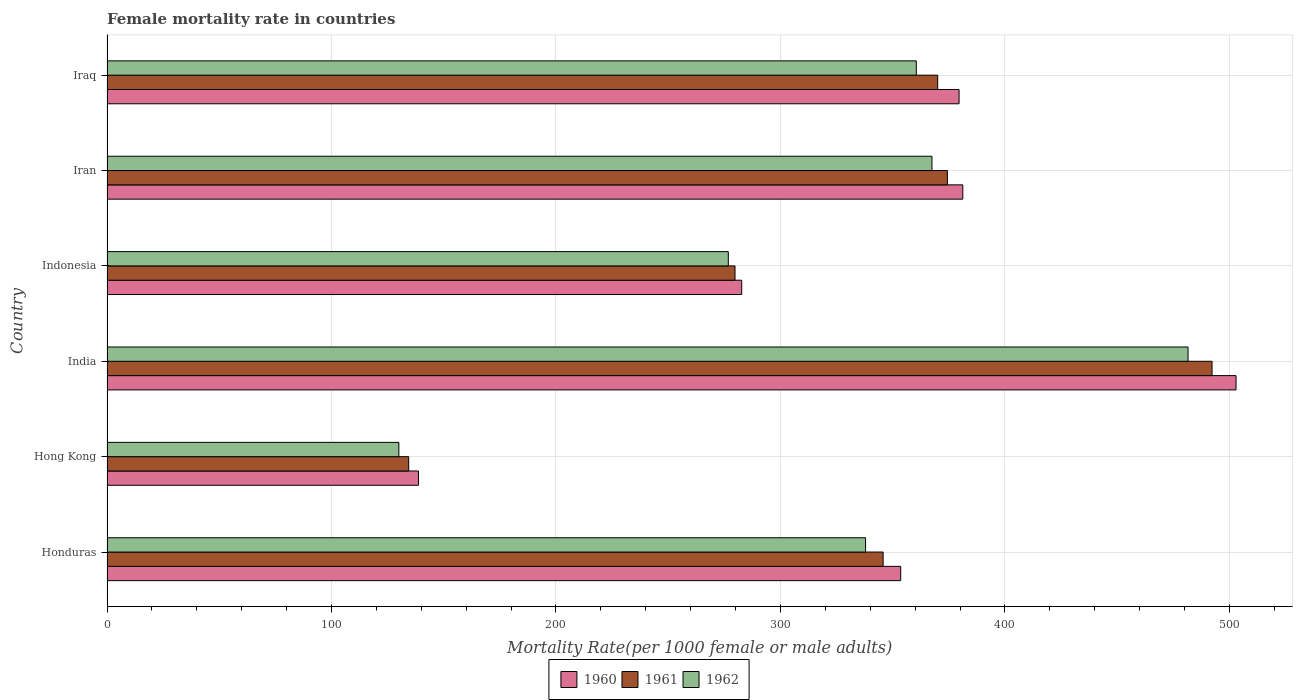How many groups of bars are there?
Make the answer very short. 6. Are the number of bars per tick equal to the number of legend labels?
Your answer should be compact. Yes. Are the number of bars on each tick of the Y-axis equal?
Your response must be concise. Yes. How many bars are there on the 4th tick from the top?
Keep it short and to the point. 3. How many bars are there on the 2nd tick from the bottom?
Your response must be concise. 3. What is the label of the 1st group of bars from the top?
Ensure brevity in your answer.  Iraq. What is the female mortality rate in 1962 in Hong Kong?
Your answer should be very brief. 130.02. Across all countries, what is the maximum female mortality rate in 1961?
Offer a terse response. 492.27. Across all countries, what is the minimum female mortality rate in 1961?
Offer a terse response. 134.39. In which country was the female mortality rate in 1962 maximum?
Your response must be concise. India. In which country was the female mortality rate in 1960 minimum?
Ensure brevity in your answer.  Hong Kong. What is the total female mortality rate in 1962 in the graph?
Provide a short and direct response. 1954.32. What is the difference between the female mortality rate in 1962 in Honduras and that in India?
Ensure brevity in your answer.  -143.67. What is the difference between the female mortality rate in 1961 in Hong Kong and the female mortality rate in 1962 in Indonesia?
Your response must be concise. -142.38. What is the average female mortality rate in 1960 per country?
Offer a very short reply. 339.81. What is the difference between the female mortality rate in 1960 and female mortality rate in 1962 in India?
Your answer should be compact. 21.38. In how many countries, is the female mortality rate in 1961 greater than 480 ?
Provide a succinct answer. 1. What is the ratio of the female mortality rate in 1960 in Iran to that in Iraq?
Give a very brief answer. 1. Is the female mortality rate in 1960 in Hong Kong less than that in Indonesia?
Make the answer very short. Yes. Is the difference between the female mortality rate in 1960 in Indonesia and Iran greater than the difference between the female mortality rate in 1962 in Indonesia and Iran?
Your response must be concise. No. What is the difference between the highest and the second highest female mortality rate in 1960?
Your answer should be compact. 121.72. What is the difference between the highest and the lowest female mortality rate in 1961?
Keep it short and to the point. 357.88. In how many countries, is the female mortality rate in 1960 greater than the average female mortality rate in 1960 taken over all countries?
Your answer should be very brief. 4. Is the sum of the female mortality rate in 1960 in Honduras and Indonesia greater than the maximum female mortality rate in 1961 across all countries?
Keep it short and to the point. Yes. What does the 1st bar from the bottom in Iran represents?
Make the answer very short. 1960. Is it the case that in every country, the sum of the female mortality rate in 1960 and female mortality rate in 1961 is greater than the female mortality rate in 1962?
Make the answer very short. Yes. How many bars are there?
Ensure brevity in your answer.  18. What is the difference between two consecutive major ticks on the X-axis?
Your answer should be very brief. 100. Are the values on the major ticks of X-axis written in scientific E-notation?
Your answer should be compact. No. Does the graph contain any zero values?
Your answer should be very brief. No. How many legend labels are there?
Your answer should be very brief. 3. How are the legend labels stacked?
Offer a terse response. Horizontal. What is the title of the graph?
Give a very brief answer. Female mortality rate in countries. What is the label or title of the X-axis?
Your answer should be very brief. Mortality Rate(per 1000 female or male adults). What is the Mortality Rate(per 1000 female or male adults) in 1960 in Honduras?
Make the answer very short. 353.57. What is the Mortality Rate(per 1000 female or male adults) in 1961 in Honduras?
Ensure brevity in your answer.  345.74. What is the Mortality Rate(per 1000 female or male adults) in 1962 in Honduras?
Make the answer very short. 337.91. What is the Mortality Rate(per 1000 female or male adults) of 1960 in Hong Kong?
Offer a very short reply. 138.77. What is the Mortality Rate(per 1000 female or male adults) of 1961 in Hong Kong?
Provide a short and direct response. 134.39. What is the Mortality Rate(per 1000 female or male adults) in 1962 in Hong Kong?
Provide a short and direct response. 130.02. What is the Mortality Rate(per 1000 female or male adults) of 1960 in India?
Offer a terse response. 502.96. What is the Mortality Rate(per 1000 female or male adults) of 1961 in India?
Make the answer very short. 492.27. What is the Mortality Rate(per 1000 female or male adults) in 1962 in India?
Provide a short and direct response. 481.58. What is the Mortality Rate(per 1000 female or male adults) in 1960 in Indonesia?
Provide a succinct answer. 282.75. What is the Mortality Rate(per 1000 female or male adults) in 1961 in Indonesia?
Offer a very short reply. 279.76. What is the Mortality Rate(per 1000 female or male adults) of 1962 in Indonesia?
Offer a very short reply. 276.78. What is the Mortality Rate(per 1000 female or male adults) of 1960 in Iran?
Your response must be concise. 381.24. What is the Mortality Rate(per 1000 female or male adults) in 1961 in Iran?
Give a very brief answer. 374.37. What is the Mortality Rate(per 1000 female or male adults) in 1962 in Iran?
Offer a very short reply. 367.5. What is the Mortality Rate(per 1000 female or male adults) of 1960 in Iraq?
Provide a succinct answer. 379.58. What is the Mortality Rate(per 1000 female or male adults) of 1961 in Iraq?
Make the answer very short. 370.06. What is the Mortality Rate(per 1000 female or male adults) in 1962 in Iraq?
Your answer should be compact. 360.53. Across all countries, what is the maximum Mortality Rate(per 1000 female or male adults) in 1960?
Provide a succinct answer. 502.96. Across all countries, what is the maximum Mortality Rate(per 1000 female or male adults) in 1961?
Your response must be concise. 492.27. Across all countries, what is the maximum Mortality Rate(per 1000 female or male adults) in 1962?
Your answer should be very brief. 481.58. Across all countries, what is the minimum Mortality Rate(per 1000 female or male adults) in 1960?
Ensure brevity in your answer.  138.77. Across all countries, what is the minimum Mortality Rate(per 1000 female or male adults) in 1961?
Offer a terse response. 134.39. Across all countries, what is the minimum Mortality Rate(per 1000 female or male adults) of 1962?
Give a very brief answer. 130.02. What is the total Mortality Rate(per 1000 female or male adults) in 1960 in the graph?
Ensure brevity in your answer.  2038.88. What is the total Mortality Rate(per 1000 female or male adults) of 1961 in the graph?
Your answer should be very brief. 1996.6. What is the total Mortality Rate(per 1000 female or male adults) in 1962 in the graph?
Give a very brief answer. 1954.32. What is the difference between the Mortality Rate(per 1000 female or male adults) of 1960 in Honduras and that in Hong Kong?
Keep it short and to the point. 214.8. What is the difference between the Mortality Rate(per 1000 female or male adults) of 1961 in Honduras and that in Hong Kong?
Make the answer very short. 211.35. What is the difference between the Mortality Rate(per 1000 female or male adults) of 1962 in Honduras and that in Hong Kong?
Your answer should be very brief. 207.89. What is the difference between the Mortality Rate(per 1000 female or male adults) of 1960 in Honduras and that in India?
Offer a very short reply. -149.39. What is the difference between the Mortality Rate(per 1000 female or male adults) of 1961 in Honduras and that in India?
Make the answer very short. -146.53. What is the difference between the Mortality Rate(per 1000 female or male adults) of 1962 in Honduras and that in India?
Ensure brevity in your answer.  -143.67. What is the difference between the Mortality Rate(per 1000 female or male adults) of 1960 in Honduras and that in Indonesia?
Provide a succinct answer. 70.82. What is the difference between the Mortality Rate(per 1000 female or male adults) of 1961 in Honduras and that in Indonesia?
Give a very brief answer. 65.98. What is the difference between the Mortality Rate(per 1000 female or male adults) in 1962 in Honduras and that in Indonesia?
Ensure brevity in your answer.  61.13. What is the difference between the Mortality Rate(per 1000 female or male adults) of 1960 in Honduras and that in Iran?
Ensure brevity in your answer.  -27.67. What is the difference between the Mortality Rate(per 1000 female or male adults) in 1961 in Honduras and that in Iran?
Provide a short and direct response. -28.63. What is the difference between the Mortality Rate(per 1000 female or male adults) of 1962 in Honduras and that in Iran?
Keep it short and to the point. -29.59. What is the difference between the Mortality Rate(per 1000 female or male adults) in 1960 in Honduras and that in Iraq?
Your answer should be compact. -26.01. What is the difference between the Mortality Rate(per 1000 female or male adults) of 1961 in Honduras and that in Iraq?
Keep it short and to the point. -24.31. What is the difference between the Mortality Rate(per 1000 female or male adults) in 1962 in Honduras and that in Iraq?
Provide a short and direct response. -22.62. What is the difference between the Mortality Rate(per 1000 female or male adults) of 1960 in Hong Kong and that in India?
Provide a succinct answer. -364.19. What is the difference between the Mortality Rate(per 1000 female or male adults) of 1961 in Hong Kong and that in India?
Make the answer very short. -357.88. What is the difference between the Mortality Rate(per 1000 female or male adults) of 1962 in Hong Kong and that in India?
Keep it short and to the point. -351.56. What is the difference between the Mortality Rate(per 1000 female or male adults) in 1960 in Hong Kong and that in Indonesia?
Your response must be concise. -143.98. What is the difference between the Mortality Rate(per 1000 female or male adults) in 1961 in Hong Kong and that in Indonesia?
Your answer should be compact. -145.37. What is the difference between the Mortality Rate(per 1000 female or male adults) in 1962 in Hong Kong and that in Indonesia?
Offer a very short reply. -146.76. What is the difference between the Mortality Rate(per 1000 female or male adults) in 1960 in Hong Kong and that in Iran?
Give a very brief answer. -242.47. What is the difference between the Mortality Rate(per 1000 female or male adults) of 1961 in Hong Kong and that in Iran?
Offer a very short reply. -239.98. What is the difference between the Mortality Rate(per 1000 female or male adults) in 1962 in Hong Kong and that in Iran?
Keep it short and to the point. -237.48. What is the difference between the Mortality Rate(per 1000 female or male adults) in 1960 in Hong Kong and that in Iraq?
Provide a short and direct response. -240.81. What is the difference between the Mortality Rate(per 1000 female or male adults) in 1961 in Hong Kong and that in Iraq?
Your answer should be very brief. -235.66. What is the difference between the Mortality Rate(per 1000 female or male adults) in 1962 in Hong Kong and that in Iraq?
Your answer should be compact. -230.51. What is the difference between the Mortality Rate(per 1000 female or male adults) of 1960 in India and that in Indonesia?
Give a very brief answer. 220.21. What is the difference between the Mortality Rate(per 1000 female or male adults) of 1961 in India and that in Indonesia?
Offer a terse response. 212.51. What is the difference between the Mortality Rate(per 1000 female or male adults) of 1962 in India and that in Indonesia?
Offer a terse response. 204.81. What is the difference between the Mortality Rate(per 1000 female or male adults) of 1960 in India and that in Iran?
Ensure brevity in your answer.  121.72. What is the difference between the Mortality Rate(per 1000 female or male adults) in 1961 in India and that in Iran?
Provide a short and direct response. 117.9. What is the difference between the Mortality Rate(per 1000 female or male adults) of 1962 in India and that in Iran?
Keep it short and to the point. 114.08. What is the difference between the Mortality Rate(per 1000 female or male adults) of 1960 in India and that in Iraq?
Ensure brevity in your answer.  123.38. What is the difference between the Mortality Rate(per 1000 female or male adults) of 1961 in India and that in Iraq?
Provide a succinct answer. 122.22. What is the difference between the Mortality Rate(per 1000 female or male adults) in 1962 in India and that in Iraq?
Offer a very short reply. 121.05. What is the difference between the Mortality Rate(per 1000 female or male adults) of 1960 in Indonesia and that in Iran?
Provide a succinct answer. -98.49. What is the difference between the Mortality Rate(per 1000 female or male adults) of 1961 in Indonesia and that in Iran?
Offer a very short reply. -94.6. What is the difference between the Mortality Rate(per 1000 female or male adults) in 1962 in Indonesia and that in Iran?
Provide a succinct answer. -90.72. What is the difference between the Mortality Rate(per 1000 female or male adults) of 1960 in Indonesia and that in Iraq?
Provide a short and direct response. -96.83. What is the difference between the Mortality Rate(per 1000 female or male adults) in 1961 in Indonesia and that in Iraq?
Provide a succinct answer. -90.29. What is the difference between the Mortality Rate(per 1000 female or male adults) of 1962 in Indonesia and that in Iraq?
Offer a very short reply. -83.75. What is the difference between the Mortality Rate(per 1000 female or male adults) in 1960 in Iran and that in Iraq?
Your response must be concise. 1.66. What is the difference between the Mortality Rate(per 1000 female or male adults) in 1961 in Iran and that in Iraq?
Provide a succinct answer. 4.31. What is the difference between the Mortality Rate(per 1000 female or male adults) of 1962 in Iran and that in Iraq?
Your response must be concise. 6.97. What is the difference between the Mortality Rate(per 1000 female or male adults) of 1960 in Honduras and the Mortality Rate(per 1000 female or male adults) of 1961 in Hong Kong?
Offer a terse response. 219.18. What is the difference between the Mortality Rate(per 1000 female or male adults) in 1960 in Honduras and the Mortality Rate(per 1000 female or male adults) in 1962 in Hong Kong?
Ensure brevity in your answer.  223.56. What is the difference between the Mortality Rate(per 1000 female or male adults) of 1961 in Honduras and the Mortality Rate(per 1000 female or male adults) of 1962 in Hong Kong?
Your response must be concise. 215.72. What is the difference between the Mortality Rate(per 1000 female or male adults) of 1960 in Honduras and the Mortality Rate(per 1000 female or male adults) of 1961 in India?
Provide a succinct answer. -138.7. What is the difference between the Mortality Rate(per 1000 female or male adults) in 1960 in Honduras and the Mortality Rate(per 1000 female or male adults) in 1962 in India?
Provide a short and direct response. -128.01. What is the difference between the Mortality Rate(per 1000 female or male adults) of 1961 in Honduras and the Mortality Rate(per 1000 female or male adults) of 1962 in India?
Ensure brevity in your answer.  -135.84. What is the difference between the Mortality Rate(per 1000 female or male adults) in 1960 in Honduras and the Mortality Rate(per 1000 female or male adults) in 1961 in Indonesia?
Give a very brief answer. 73.81. What is the difference between the Mortality Rate(per 1000 female or male adults) in 1960 in Honduras and the Mortality Rate(per 1000 female or male adults) in 1962 in Indonesia?
Make the answer very short. 76.8. What is the difference between the Mortality Rate(per 1000 female or male adults) of 1961 in Honduras and the Mortality Rate(per 1000 female or male adults) of 1962 in Indonesia?
Your answer should be very brief. 68.97. What is the difference between the Mortality Rate(per 1000 female or male adults) in 1960 in Honduras and the Mortality Rate(per 1000 female or male adults) in 1961 in Iran?
Provide a succinct answer. -20.8. What is the difference between the Mortality Rate(per 1000 female or male adults) of 1960 in Honduras and the Mortality Rate(per 1000 female or male adults) of 1962 in Iran?
Keep it short and to the point. -13.93. What is the difference between the Mortality Rate(per 1000 female or male adults) of 1961 in Honduras and the Mortality Rate(per 1000 female or male adults) of 1962 in Iran?
Offer a very short reply. -21.76. What is the difference between the Mortality Rate(per 1000 female or male adults) in 1960 in Honduras and the Mortality Rate(per 1000 female or male adults) in 1961 in Iraq?
Give a very brief answer. -16.48. What is the difference between the Mortality Rate(per 1000 female or male adults) of 1960 in Honduras and the Mortality Rate(per 1000 female or male adults) of 1962 in Iraq?
Offer a very short reply. -6.96. What is the difference between the Mortality Rate(per 1000 female or male adults) in 1961 in Honduras and the Mortality Rate(per 1000 female or male adults) in 1962 in Iraq?
Your answer should be compact. -14.79. What is the difference between the Mortality Rate(per 1000 female or male adults) of 1960 in Hong Kong and the Mortality Rate(per 1000 female or male adults) of 1961 in India?
Keep it short and to the point. -353.5. What is the difference between the Mortality Rate(per 1000 female or male adults) of 1960 in Hong Kong and the Mortality Rate(per 1000 female or male adults) of 1962 in India?
Your answer should be compact. -342.81. What is the difference between the Mortality Rate(per 1000 female or male adults) in 1961 in Hong Kong and the Mortality Rate(per 1000 female or male adults) in 1962 in India?
Give a very brief answer. -347.19. What is the difference between the Mortality Rate(per 1000 female or male adults) in 1960 in Hong Kong and the Mortality Rate(per 1000 female or male adults) in 1961 in Indonesia?
Give a very brief answer. -141. What is the difference between the Mortality Rate(per 1000 female or male adults) in 1960 in Hong Kong and the Mortality Rate(per 1000 female or male adults) in 1962 in Indonesia?
Give a very brief answer. -138.01. What is the difference between the Mortality Rate(per 1000 female or male adults) of 1961 in Hong Kong and the Mortality Rate(per 1000 female or male adults) of 1962 in Indonesia?
Your response must be concise. -142.38. What is the difference between the Mortality Rate(per 1000 female or male adults) in 1960 in Hong Kong and the Mortality Rate(per 1000 female or male adults) in 1961 in Iran?
Your response must be concise. -235.6. What is the difference between the Mortality Rate(per 1000 female or male adults) in 1960 in Hong Kong and the Mortality Rate(per 1000 female or male adults) in 1962 in Iran?
Make the answer very short. -228.73. What is the difference between the Mortality Rate(per 1000 female or male adults) in 1961 in Hong Kong and the Mortality Rate(per 1000 female or male adults) in 1962 in Iran?
Your response must be concise. -233.1. What is the difference between the Mortality Rate(per 1000 female or male adults) in 1960 in Hong Kong and the Mortality Rate(per 1000 female or male adults) in 1961 in Iraq?
Your response must be concise. -231.29. What is the difference between the Mortality Rate(per 1000 female or male adults) of 1960 in Hong Kong and the Mortality Rate(per 1000 female or male adults) of 1962 in Iraq?
Offer a very short reply. -221.76. What is the difference between the Mortality Rate(per 1000 female or male adults) in 1961 in Hong Kong and the Mortality Rate(per 1000 female or male adults) in 1962 in Iraq?
Your answer should be very brief. -226.14. What is the difference between the Mortality Rate(per 1000 female or male adults) in 1960 in India and the Mortality Rate(per 1000 female or male adults) in 1961 in Indonesia?
Make the answer very short. 223.2. What is the difference between the Mortality Rate(per 1000 female or male adults) in 1960 in India and the Mortality Rate(per 1000 female or male adults) in 1962 in Indonesia?
Ensure brevity in your answer.  226.18. What is the difference between the Mortality Rate(per 1000 female or male adults) of 1961 in India and the Mortality Rate(per 1000 female or male adults) of 1962 in Indonesia?
Give a very brief answer. 215.5. What is the difference between the Mortality Rate(per 1000 female or male adults) in 1960 in India and the Mortality Rate(per 1000 female or male adults) in 1961 in Iran?
Provide a succinct answer. 128.59. What is the difference between the Mortality Rate(per 1000 female or male adults) in 1960 in India and the Mortality Rate(per 1000 female or male adults) in 1962 in Iran?
Provide a short and direct response. 135.46. What is the difference between the Mortality Rate(per 1000 female or male adults) of 1961 in India and the Mortality Rate(per 1000 female or male adults) of 1962 in Iran?
Provide a succinct answer. 124.77. What is the difference between the Mortality Rate(per 1000 female or male adults) of 1960 in India and the Mortality Rate(per 1000 female or male adults) of 1961 in Iraq?
Keep it short and to the point. 132.91. What is the difference between the Mortality Rate(per 1000 female or male adults) of 1960 in India and the Mortality Rate(per 1000 female or male adults) of 1962 in Iraq?
Offer a terse response. 142.43. What is the difference between the Mortality Rate(per 1000 female or male adults) of 1961 in India and the Mortality Rate(per 1000 female or male adults) of 1962 in Iraq?
Provide a short and direct response. 131.74. What is the difference between the Mortality Rate(per 1000 female or male adults) of 1960 in Indonesia and the Mortality Rate(per 1000 female or male adults) of 1961 in Iran?
Your answer should be very brief. -91.62. What is the difference between the Mortality Rate(per 1000 female or male adults) in 1960 in Indonesia and the Mortality Rate(per 1000 female or male adults) in 1962 in Iran?
Offer a terse response. -84.75. What is the difference between the Mortality Rate(per 1000 female or male adults) of 1961 in Indonesia and the Mortality Rate(per 1000 female or male adults) of 1962 in Iran?
Your answer should be very brief. -87.73. What is the difference between the Mortality Rate(per 1000 female or male adults) in 1960 in Indonesia and the Mortality Rate(per 1000 female or male adults) in 1961 in Iraq?
Provide a short and direct response. -87.3. What is the difference between the Mortality Rate(per 1000 female or male adults) of 1960 in Indonesia and the Mortality Rate(per 1000 female or male adults) of 1962 in Iraq?
Make the answer very short. -77.78. What is the difference between the Mortality Rate(per 1000 female or male adults) of 1961 in Indonesia and the Mortality Rate(per 1000 female or male adults) of 1962 in Iraq?
Offer a very short reply. -80.77. What is the difference between the Mortality Rate(per 1000 female or male adults) in 1960 in Iran and the Mortality Rate(per 1000 female or male adults) in 1961 in Iraq?
Your answer should be very brief. 11.19. What is the difference between the Mortality Rate(per 1000 female or male adults) in 1960 in Iran and the Mortality Rate(per 1000 female or male adults) in 1962 in Iraq?
Your answer should be compact. 20.71. What is the difference between the Mortality Rate(per 1000 female or male adults) of 1961 in Iran and the Mortality Rate(per 1000 female or male adults) of 1962 in Iraq?
Keep it short and to the point. 13.84. What is the average Mortality Rate(per 1000 female or male adults) in 1960 per country?
Offer a terse response. 339.81. What is the average Mortality Rate(per 1000 female or male adults) in 1961 per country?
Make the answer very short. 332.77. What is the average Mortality Rate(per 1000 female or male adults) of 1962 per country?
Offer a very short reply. 325.72. What is the difference between the Mortality Rate(per 1000 female or male adults) of 1960 and Mortality Rate(per 1000 female or male adults) of 1961 in Honduras?
Provide a short and direct response. 7.83. What is the difference between the Mortality Rate(per 1000 female or male adults) of 1960 and Mortality Rate(per 1000 female or male adults) of 1962 in Honduras?
Make the answer very short. 15.66. What is the difference between the Mortality Rate(per 1000 female or male adults) in 1961 and Mortality Rate(per 1000 female or male adults) in 1962 in Honduras?
Offer a very short reply. 7.83. What is the difference between the Mortality Rate(per 1000 female or male adults) in 1960 and Mortality Rate(per 1000 female or male adults) in 1961 in Hong Kong?
Offer a terse response. 4.38. What is the difference between the Mortality Rate(per 1000 female or male adults) of 1960 and Mortality Rate(per 1000 female or male adults) of 1962 in Hong Kong?
Keep it short and to the point. 8.75. What is the difference between the Mortality Rate(per 1000 female or male adults) in 1961 and Mortality Rate(per 1000 female or male adults) in 1962 in Hong Kong?
Offer a terse response. 4.38. What is the difference between the Mortality Rate(per 1000 female or male adults) in 1960 and Mortality Rate(per 1000 female or male adults) in 1961 in India?
Keep it short and to the point. 10.69. What is the difference between the Mortality Rate(per 1000 female or male adults) in 1960 and Mortality Rate(per 1000 female or male adults) in 1962 in India?
Give a very brief answer. 21.38. What is the difference between the Mortality Rate(per 1000 female or male adults) of 1961 and Mortality Rate(per 1000 female or male adults) of 1962 in India?
Your answer should be very brief. 10.69. What is the difference between the Mortality Rate(per 1000 female or male adults) in 1960 and Mortality Rate(per 1000 female or male adults) in 1961 in Indonesia?
Ensure brevity in your answer.  2.99. What is the difference between the Mortality Rate(per 1000 female or male adults) in 1960 and Mortality Rate(per 1000 female or male adults) in 1962 in Indonesia?
Your answer should be compact. 5.98. What is the difference between the Mortality Rate(per 1000 female or male adults) of 1961 and Mortality Rate(per 1000 female or male adults) of 1962 in Indonesia?
Give a very brief answer. 2.99. What is the difference between the Mortality Rate(per 1000 female or male adults) in 1960 and Mortality Rate(per 1000 female or male adults) in 1961 in Iran?
Provide a short and direct response. 6.87. What is the difference between the Mortality Rate(per 1000 female or male adults) of 1960 and Mortality Rate(per 1000 female or male adults) of 1962 in Iran?
Provide a succinct answer. 13.74. What is the difference between the Mortality Rate(per 1000 female or male adults) in 1961 and Mortality Rate(per 1000 female or male adults) in 1962 in Iran?
Your response must be concise. 6.87. What is the difference between the Mortality Rate(per 1000 female or male adults) of 1960 and Mortality Rate(per 1000 female or male adults) of 1961 in Iraq?
Provide a succinct answer. 9.53. What is the difference between the Mortality Rate(per 1000 female or male adults) in 1960 and Mortality Rate(per 1000 female or male adults) in 1962 in Iraq?
Keep it short and to the point. 19.05. What is the difference between the Mortality Rate(per 1000 female or male adults) in 1961 and Mortality Rate(per 1000 female or male adults) in 1962 in Iraq?
Your answer should be compact. 9.53. What is the ratio of the Mortality Rate(per 1000 female or male adults) in 1960 in Honduras to that in Hong Kong?
Provide a succinct answer. 2.55. What is the ratio of the Mortality Rate(per 1000 female or male adults) in 1961 in Honduras to that in Hong Kong?
Give a very brief answer. 2.57. What is the ratio of the Mortality Rate(per 1000 female or male adults) of 1962 in Honduras to that in Hong Kong?
Your answer should be compact. 2.6. What is the ratio of the Mortality Rate(per 1000 female or male adults) in 1960 in Honduras to that in India?
Your answer should be very brief. 0.7. What is the ratio of the Mortality Rate(per 1000 female or male adults) of 1961 in Honduras to that in India?
Ensure brevity in your answer.  0.7. What is the ratio of the Mortality Rate(per 1000 female or male adults) in 1962 in Honduras to that in India?
Your response must be concise. 0.7. What is the ratio of the Mortality Rate(per 1000 female or male adults) of 1960 in Honduras to that in Indonesia?
Make the answer very short. 1.25. What is the ratio of the Mortality Rate(per 1000 female or male adults) of 1961 in Honduras to that in Indonesia?
Provide a succinct answer. 1.24. What is the ratio of the Mortality Rate(per 1000 female or male adults) in 1962 in Honduras to that in Indonesia?
Provide a short and direct response. 1.22. What is the ratio of the Mortality Rate(per 1000 female or male adults) in 1960 in Honduras to that in Iran?
Your answer should be compact. 0.93. What is the ratio of the Mortality Rate(per 1000 female or male adults) of 1961 in Honduras to that in Iran?
Offer a very short reply. 0.92. What is the ratio of the Mortality Rate(per 1000 female or male adults) of 1962 in Honduras to that in Iran?
Your response must be concise. 0.92. What is the ratio of the Mortality Rate(per 1000 female or male adults) in 1960 in Honduras to that in Iraq?
Your answer should be compact. 0.93. What is the ratio of the Mortality Rate(per 1000 female or male adults) of 1961 in Honduras to that in Iraq?
Provide a succinct answer. 0.93. What is the ratio of the Mortality Rate(per 1000 female or male adults) in 1962 in Honduras to that in Iraq?
Provide a succinct answer. 0.94. What is the ratio of the Mortality Rate(per 1000 female or male adults) in 1960 in Hong Kong to that in India?
Ensure brevity in your answer.  0.28. What is the ratio of the Mortality Rate(per 1000 female or male adults) of 1961 in Hong Kong to that in India?
Provide a succinct answer. 0.27. What is the ratio of the Mortality Rate(per 1000 female or male adults) in 1962 in Hong Kong to that in India?
Make the answer very short. 0.27. What is the ratio of the Mortality Rate(per 1000 female or male adults) in 1960 in Hong Kong to that in Indonesia?
Provide a short and direct response. 0.49. What is the ratio of the Mortality Rate(per 1000 female or male adults) of 1961 in Hong Kong to that in Indonesia?
Provide a succinct answer. 0.48. What is the ratio of the Mortality Rate(per 1000 female or male adults) in 1962 in Hong Kong to that in Indonesia?
Keep it short and to the point. 0.47. What is the ratio of the Mortality Rate(per 1000 female or male adults) in 1960 in Hong Kong to that in Iran?
Make the answer very short. 0.36. What is the ratio of the Mortality Rate(per 1000 female or male adults) of 1961 in Hong Kong to that in Iran?
Give a very brief answer. 0.36. What is the ratio of the Mortality Rate(per 1000 female or male adults) in 1962 in Hong Kong to that in Iran?
Provide a succinct answer. 0.35. What is the ratio of the Mortality Rate(per 1000 female or male adults) of 1960 in Hong Kong to that in Iraq?
Your answer should be very brief. 0.37. What is the ratio of the Mortality Rate(per 1000 female or male adults) in 1961 in Hong Kong to that in Iraq?
Offer a very short reply. 0.36. What is the ratio of the Mortality Rate(per 1000 female or male adults) of 1962 in Hong Kong to that in Iraq?
Your response must be concise. 0.36. What is the ratio of the Mortality Rate(per 1000 female or male adults) in 1960 in India to that in Indonesia?
Your response must be concise. 1.78. What is the ratio of the Mortality Rate(per 1000 female or male adults) in 1961 in India to that in Indonesia?
Your response must be concise. 1.76. What is the ratio of the Mortality Rate(per 1000 female or male adults) of 1962 in India to that in Indonesia?
Your response must be concise. 1.74. What is the ratio of the Mortality Rate(per 1000 female or male adults) of 1960 in India to that in Iran?
Provide a short and direct response. 1.32. What is the ratio of the Mortality Rate(per 1000 female or male adults) in 1961 in India to that in Iran?
Provide a succinct answer. 1.31. What is the ratio of the Mortality Rate(per 1000 female or male adults) in 1962 in India to that in Iran?
Make the answer very short. 1.31. What is the ratio of the Mortality Rate(per 1000 female or male adults) in 1960 in India to that in Iraq?
Provide a succinct answer. 1.32. What is the ratio of the Mortality Rate(per 1000 female or male adults) of 1961 in India to that in Iraq?
Your response must be concise. 1.33. What is the ratio of the Mortality Rate(per 1000 female or male adults) in 1962 in India to that in Iraq?
Offer a terse response. 1.34. What is the ratio of the Mortality Rate(per 1000 female or male adults) in 1960 in Indonesia to that in Iran?
Give a very brief answer. 0.74. What is the ratio of the Mortality Rate(per 1000 female or male adults) in 1961 in Indonesia to that in Iran?
Ensure brevity in your answer.  0.75. What is the ratio of the Mortality Rate(per 1000 female or male adults) of 1962 in Indonesia to that in Iran?
Your answer should be compact. 0.75. What is the ratio of the Mortality Rate(per 1000 female or male adults) in 1960 in Indonesia to that in Iraq?
Provide a short and direct response. 0.74. What is the ratio of the Mortality Rate(per 1000 female or male adults) of 1961 in Indonesia to that in Iraq?
Offer a very short reply. 0.76. What is the ratio of the Mortality Rate(per 1000 female or male adults) of 1962 in Indonesia to that in Iraq?
Provide a short and direct response. 0.77. What is the ratio of the Mortality Rate(per 1000 female or male adults) in 1961 in Iran to that in Iraq?
Keep it short and to the point. 1.01. What is the ratio of the Mortality Rate(per 1000 female or male adults) in 1962 in Iran to that in Iraq?
Keep it short and to the point. 1.02. What is the difference between the highest and the second highest Mortality Rate(per 1000 female or male adults) in 1960?
Offer a very short reply. 121.72. What is the difference between the highest and the second highest Mortality Rate(per 1000 female or male adults) of 1961?
Your answer should be very brief. 117.9. What is the difference between the highest and the second highest Mortality Rate(per 1000 female or male adults) of 1962?
Ensure brevity in your answer.  114.08. What is the difference between the highest and the lowest Mortality Rate(per 1000 female or male adults) of 1960?
Give a very brief answer. 364.19. What is the difference between the highest and the lowest Mortality Rate(per 1000 female or male adults) of 1961?
Offer a terse response. 357.88. What is the difference between the highest and the lowest Mortality Rate(per 1000 female or male adults) in 1962?
Provide a succinct answer. 351.56. 